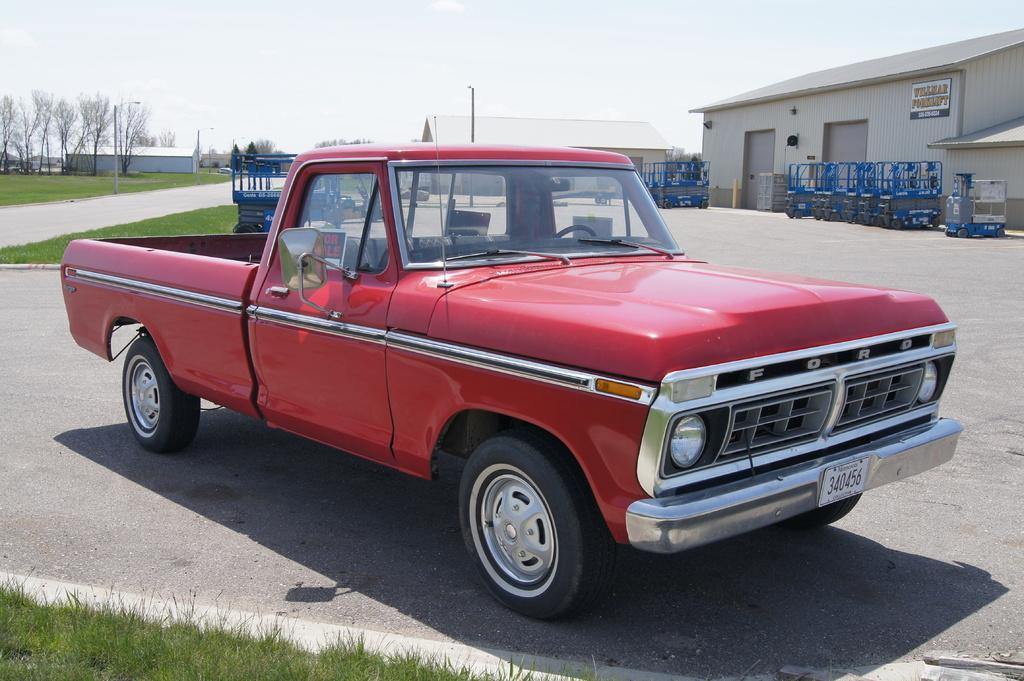Can you describe this image briefly? In this image I can see a red colour vehicle and here I can see few numbers are written. I can also see road, grass, shadow and in background I can see few poles, buildings, trees. the sky and I can see few blue colour things. Here I can see a board and on it I can see something is written. 